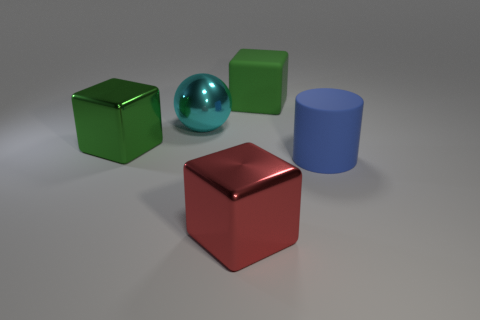Add 5 brown rubber blocks. How many objects exist? 10 Subtract all green cubes. How many cubes are left? 1 Subtract all cylinders. How many objects are left? 4 Subtract all purple balls. Subtract all green cubes. How many balls are left? 1 Subtract all green blocks. How many gray spheres are left? 0 Subtract all green shiny things. Subtract all blue things. How many objects are left? 3 Add 3 shiny things. How many shiny things are left? 6 Add 5 rubber cubes. How many rubber cubes exist? 6 Subtract all red blocks. How many blocks are left? 2 Subtract 1 cyan spheres. How many objects are left? 4 